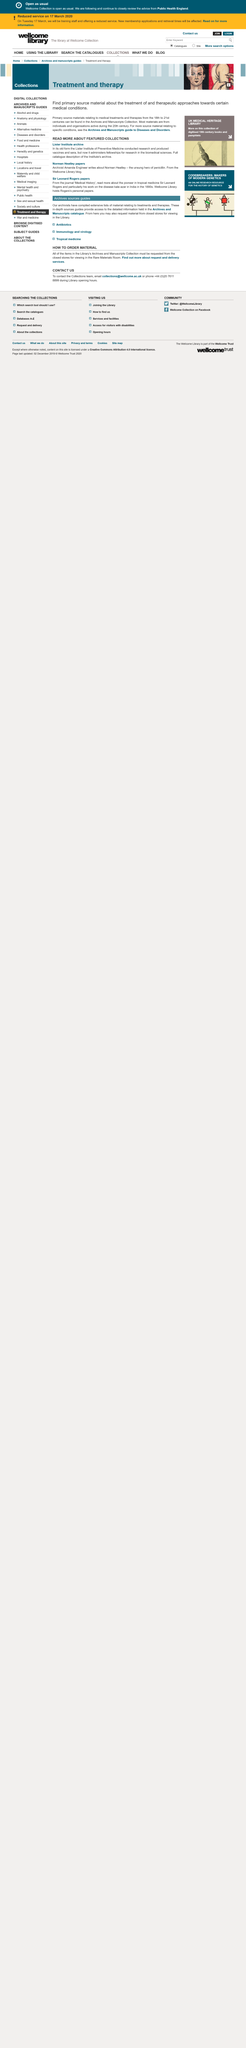Identify some key points in this picture. Norman's second name is Heatley. Sir Leonard Rogers was a pioneer in the field of tropical medicine. The Lister Institute administers fellowships for biomedical sciences. 